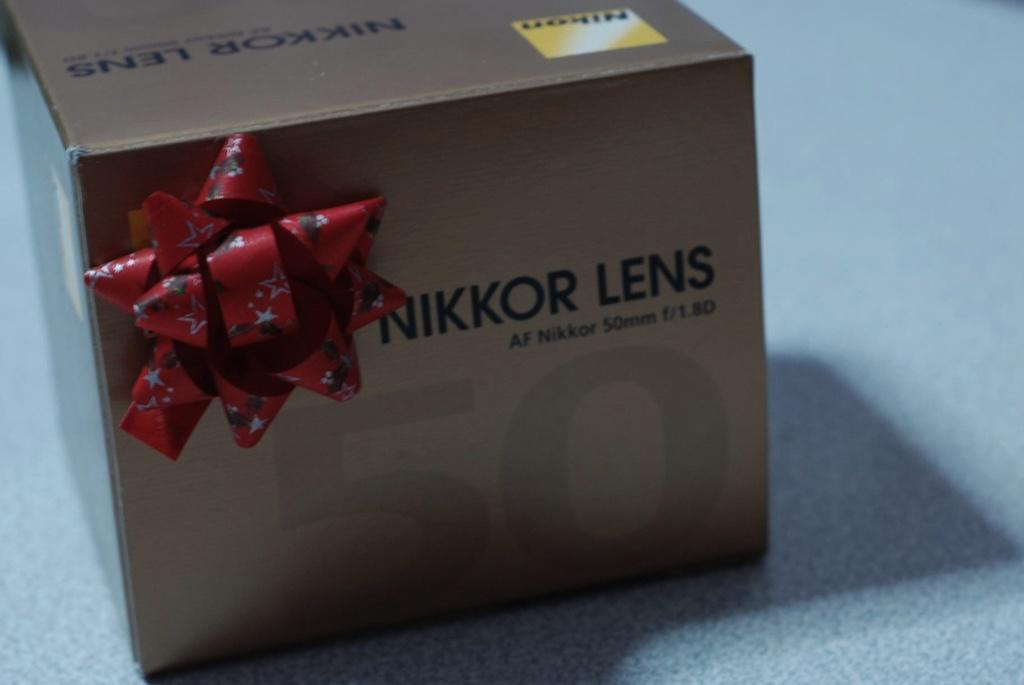<image>
Offer a succinct explanation of the picture presented. a box for Nikkor Lens has a pretty red bow on the front 